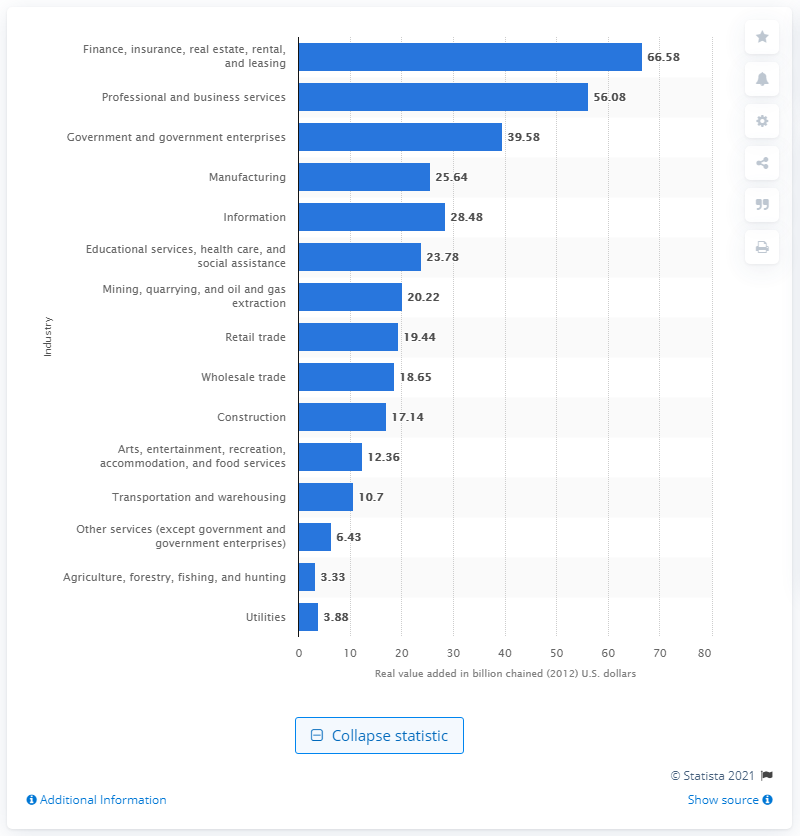Point out several critical features in this image. The mining industry added $20.22 billion to Colorado's GDP in 2012. 